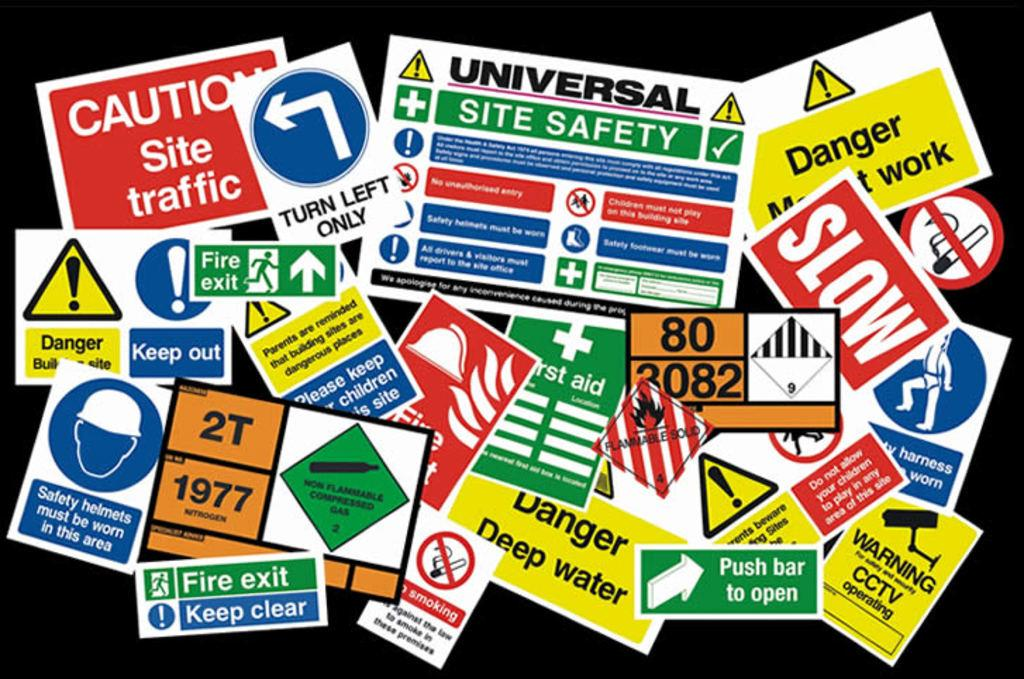<image>
Summarize the visual content of the image. Collage of stickers and signs with one saying "Caution Site Traffic". 